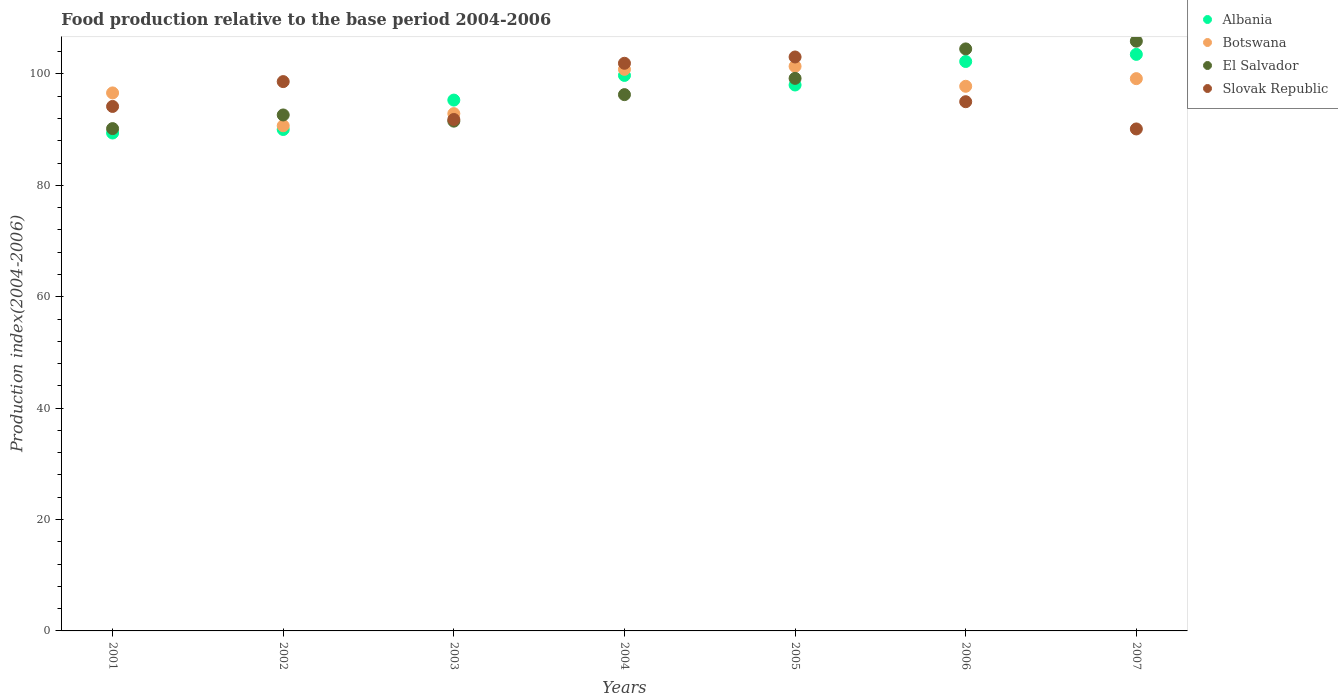Is the number of dotlines equal to the number of legend labels?
Your answer should be very brief. Yes. What is the food production index in Albania in 2006?
Offer a very short reply. 102.24. Across all years, what is the maximum food production index in Slovak Republic?
Keep it short and to the point. 103.05. Across all years, what is the minimum food production index in Slovak Republic?
Make the answer very short. 90.13. In which year was the food production index in Botswana maximum?
Make the answer very short. 2005. What is the total food production index in Botswana in the graph?
Ensure brevity in your answer.  679.33. What is the difference between the food production index in Botswana in 2004 and that in 2007?
Your answer should be compact. 1.67. What is the difference between the food production index in Albania in 2002 and the food production index in El Salvador in 2005?
Provide a succinct answer. -9.18. What is the average food production index in El Salvador per year?
Provide a short and direct response. 97.18. In the year 2003, what is the difference between the food production index in Botswana and food production index in Slovak Republic?
Offer a very short reply. 1.05. What is the ratio of the food production index in Botswana in 2001 to that in 2007?
Keep it short and to the point. 0.97. What is the difference between the highest and the second highest food production index in Albania?
Your response must be concise. 1.28. What is the difference between the highest and the lowest food production index in Albania?
Provide a short and direct response. 14.12. In how many years, is the food production index in El Salvador greater than the average food production index in El Salvador taken over all years?
Keep it short and to the point. 3. Is the food production index in Slovak Republic strictly greater than the food production index in Albania over the years?
Make the answer very short. No. Is the food production index in Slovak Republic strictly less than the food production index in El Salvador over the years?
Make the answer very short. No. Are the values on the major ticks of Y-axis written in scientific E-notation?
Your answer should be very brief. No. Where does the legend appear in the graph?
Your response must be concise. Top right. How are the legend labels stacked?
Your response must be concise. Vertical. What is the title of the graph?
Your answer should be compact. Food production relative to the base period 2004-2006. What is the label or title of the Y-axis?
Offer a very short reply. Production index(2004-2006). What is the Production index(2004-2006) in Albania in 2001?
Offer a very short reply. 89.4. What is the Production index(2004-2006) in Botswana in 2001?
Your answer should be very brief. 96.6. What is the Production index(2004-2006) in El Salvador in 2001?
Offer a terse response. 90.19. What is the Production index(2004-2006) of Slovak Republic in 2001?
Ensure brevity in your answer.  94.17. What is the Production index(2004-2006) in Albania in 2002?
Make the answer very short. 90.03. What is the Production index(2004-2006) of Botswana in 2002?
Give a very brief answer. 90.7. What is the Production index(2004-2006) of El Salvador in 2002?
Your answer should be compact. 92.64. What is the Production index(2004-2006) in Slovak Republic in 2002?
Provide a succinct answer. 98.63. What is the Production index(2004-2006) in Albania in 2003?
Your answer should be compact. 95.31. What is the Production index(2004-2006) in Botswana in 2003?
Offer a terse response. 92.88. What is the Production index(2004-2006) in El Salvador in 2003?
Offer a very short reply. 91.53. What is the Production index(2004-2006) in Slovak Republic in 2003?
Make the answer very short. 91.83. What is the Production index(2004-2006) in Albania in 2004?
Your answer should be very brief. 99.74. What is the Production index(2004-2006) in Botswana in 2004?
Offer a terse response. 100.83. What is the Production index(2004-2006) of El Salvador in 2004?
Keep it short and to the point. 96.29. What is the Production index(2004-2006) of Slovak Republic in 2004?
Keep it short and to the point. 101.92. What is the Production index(2004-2006) in Albania in 2005?
Provide a short and direct response. 98.02. What is the Production index(2004-2006) of Botswana in 2005?
Provide a short and direct response. 101.37. What is the Production index(2004-2006) of El Salvador in 2005?
Offer a terse response. 99.21. What is the Production index(2004-2006) in Slovak Republic in 2005?
Offer a very short reply. 103.05. What is the Production index(2004-2006) of Albania in 2006?
Ensure brevity in your answer.  102.24. What is the Production index(2004-2006) in Botswana in 2006?
Keep it short and to the point. 97.79. What is the Production index(2004-2006) of El Salvador in 2006?
Give a very brief answer. 104.5. What is the Production index(2004-2006) of Slovak Republic in 2006?
Offer a terse response. 95.02. What is the Production index(2004-2006) of Albania in 2007?
Your response must be concise. 103.52. What is the Production index(2004-2006) in Botswana in 2007?
Your response must be concise. 99.16. What is the Production index(2004-2006) in El Salvador in 2007?
Your answer should be very brief. 105.89. What is the Production index(2004-2006) of Slovak Republic in 2007?
Your response must be concise. 90.13. Across all years, what is the maximum Production index(2004-2006) in Albania?
Your answer should be compact. 103.52. Across all years, what is the maximum Production index(2004-2006) of Botswana?
Your answer should be very brief. 101.37. Across all years, what is the maximum Production index(2004-2006) in El Salvador?
Make the answer very short. 105.89. Across all years, what is the maximum Production index(2004-2006) of Slovak Republic?
Your answer should be compact. 103.05. Across all years, what is the minimum Production index(2004-2006) in Albania?
Your response must be concise. 89.4. Across all years, what is the minimum Production index(2004-2006) in Botswana?
Offer a very short reply. 90.7. Across all years, what is the minimum Production index(2004-2006) in El Salvador?
Your answer should be compact. 90.19. Across all years, what is the minimum Production index(2004-2006) of Slovak Republic?
Your answer should be compact. 90.13. What is the total Production index(2004-2006) in Albania in the graph?
Give a very brief answer. 678.26. What is the total Production index(2004-2006) in Botswana in the graph?
Give a very brief answer. 679.33. What is the total Production index(2004-2006) of El Salvador in the graph?
Offer a very short reply. 680.25. What is the total Production index(2004-2006) of Slovak Republic in the graph?
Keep it short and to the point. 674.75. What is the difference between the Production index(2004-2006) of Albania in 2001 and that in 2002?
Your response must be concise. -0.63. What is the difference between the Production index(2004-2006) in El Salvador in 2001 and that in 2002?
Make the answer very short. -2.45. What is the difference between the Production index(2004-2006) in Slovak Republic in 2001 and that in 2002?
Give a very brief answer. -4.46. What is the difference between the Production index(2004-2006) of Albania in 2001 and that in 2003?
Ensure brevity in your answer.  -5.91. What is the difference between the Production index(2004-2006) of Botswana in 2001 and that in 2003?
Give a very brief answer. 3.72. What is the difference between the Production index(2004-2006) in El Salvador in 2001 and that in 2003?
Your answer should be very brief. -1.34. What is the difference between the Production index(2004-2006) in Slovak Republic in 2001 and that in 2003?
Give a very brief answer. 2.34. What is the difference between the Production index(2004-2006) in Albania in 2001 and that in 2004?
Offer a very short reply. -10.34. What is the difference between the Production index(2004-2006) in Botswana in 2001 and that in 2004?
Your answer should be very brief. -4.23. What is the difference between the Production index(2004-2006) of Slovak Republic in 2001 and that in 2004?
Your answer should be compact. -7.75. What is the difference between the Production index(2004-2006) in Albania in 2001 and that in 2005?
Your answer should be compact. -8.62. What is the difference between the Production index(2004-2006) in Botswana in 2001 and that in 2005?
Give a very brief answer. -4.77. What is the difference between the Production index(2004-2006) of El Salvador in 2001 and that in 2005?
Make the answer very short. -9.02. What is the difference between the Production index(2004-2006) in Slovak Republic in 2001 and that in 2005?
Keep it short and to the point. -8.88. What is the difference between the Production index(2004-2006) in Albania in 2001 and that in 2006?
Offer a terse response. -12.84. What is the difference between the Production index(2004-2006) in Botswana in 2001 and that in 2006?
Your answer should be compact. -1.19. What is the difference between the Production index(2004-2006) of El Salvador in 2001 and that in 2006?
Make the answer very short. -14.31. What is the difference between the Production index(2004-2006) in Slovak Republic in 2001 and that in 2006?
Give a very brief answer. -0.85. What is the difference between the Production index(2004-2006) in Albania in 2001 and that in 2007?
Offer a terse response. -14.12. What is the difference between the Production index(2004-2006) in Botswana in 2001 and that in 2007?
Offer a terse response. -2.56. What is the difference between the Production index(2004-2006) in El Salvador in 2001 and that in 2007?
Give a very brief answer. -15.7. What is the difference between the Production index(2004-2006) of Slovak Republic in 2001 and that in 2007?
Your response must be concise. 4.04. What is the difference between the Production index(2004-2006) of Albania in 2002 and that in 2003?
Provide a succinct answer. -5.28. What is the difference between the Production index(2004-2006) of Botswana in 2002 and that in 2003?
Your response must be concise. -2.18. What is the difference between the Production index(2004-2006) in El Salvador in 2002 and that in 2003?
Provide a short and direct response. 1.11. What is the difference between the Production index(2004-2006) in Albania in 2002 and that in 2004?
Ensure brevity in your answer.  -9.71. What is the difference between the Production index(2004-2006) of Botswana in 2002 and that in 2004?
Your answer should be very brief. -10.13. What is the difference between the Production index(2004-2006) of El Salvador in 2002 and that in 2004?
Give a very brief answer. -3.65. What is the difference between the Production index(2004-2006) of Slovak Republic in 2002 and that in 2004?
Offer a very short reply. -3.29. What is the difference between the Production index(2004-2006) of Albania in 2002 and that in 2005?
Give a very brief answer. -7.99. What is the difference between the Production index(2004-2006) in Botswana in 2002 and that in 2005?
Offer a very short reply. -10.67. What is the difference between the Production index(2004-2006) of El Salvador in 2002 and that in 2005?
Provide a short and direct response. -6.57. What is the difference between the Production index(2004-2006) in Slovak Republic in 2002 and that in 2005?
Your answer should be very brief. -4.42. What is the difference between the Production index(2004-2006) in Albania in 2002 and that in 2006?
Provide a short and direct response. -12.21. What is the difference between the Production index(2004-2006) of Botswana in 2002 and that in 2006?
Give a very brief answer. -7.09. What is the difference between the Production index(2004-2006) in El Salvador in 2002 and that in 2006?
Ensure brevity in your answer.  -11.86. What is the difference between the Production index(2004-2006) of Slovak Republic in 2002 and that in 2006?
Your response must be concise. 3.61. What is the difference between the Production index(2004-2006) of Albania in 2002 and that in 2007?
Provide a succinct answer. -13.49. What is the difference between the Production index(2004-2006) in Botswana in 2002 and that in 2007?
Provide a short and direct response. -8.46. What is the difference between the Production index(2004-2006) of El Salvador in 2002 and that in 2007?
Keep it short and to the point. -13.25. What is the difference between the Production index(2004-2006) in Albania in 2003 and that in 2004?
Provide a short and direct response. -4.43. What is the difference between the Production index(2004-2006) of Botswana in 2003 and that in 2004?
Offer a very short reply. -7.95. What is the difference between the Production index(2004-2006) in El Salvador in 2003 and that in 2004?
Provide a short and direct response. -4.76. What is the difference between the Production index(2004-2006) of Slovak Republic in 2003 and that in 2004?
Ensure brevity in your answer.  -10.09. What is the difference between the Production index(2004-2006) in Albania in 2003 and that in 2005?
Make the answer very short. -2.71. What is the difference between the Production index(2004-2006) in Botswana in 2003 and that in 2005?
Provide a succinct answer. -8.49. What is the difference between the Production index(2004-2006) of El Salvador in 2003 and that in 2005?
Your answer should be very brief. -7.68. What is the difference between the Production index(2004-2006) of Slovak Republic in 2003 and that in 2005?
Ensure brevity in your answer.  -11.22. What is the difference between the Production index(2004-2006) in Albania in 2003 and that in 2006?
Offer a very short reply. -6.93. What is the difference between the Production index(2004-2006) in Botswana in 2003 and that in 2006?
Your answer should be very brief. -4.91. What is the difference between the Production index(2004-2006) in El Salvador in 2003 and that in 2006?
Offer a terse response. -12.97. What is the difference between the Production index(2004-2006) in Slovak Republic in 2003 and that in 2006?
Ensure brevity in your answer.  -3.19. What is the difference between the Production index(2004-2006) of Albania in 2003 and that in 2007?
Offer a very short reply. -8.21. What is the difference between the Production index(2004-2006) in Botswana in 2003 and that in 2007?
Provide a succinct answer. -6.28. What is the difference between the Production index(2004-2006) in El Salvador in 2003 and that in 2007?
Your answer should be compact. -14.36. What is the difference between the Production index(2004-2006) in Albania in 2004 and that in 2005?
Provide a short and direct response. 1.72. What is the difference between the Production index(2004-2006) of Botswana in 2004 and that in 2005?
Ensure brevity in your answer.  -0.54. What is the difference between the Production index(2004-2006) of El Salvador in 2004 and that in 2005?
Give a very brief answer. -2.92. What is the difference between the Production index(2004-2006) of Slovak Republic in 2004 and that in 2005?
Your answer should be very brief. -1.13. What is the difference between the Production index(2004-2006) in Botswana in 2004 and that in 2006?
Ensure brevity in your answer.  3.04. What is the difference between the Production index(2004-2006) in El Salvador in 2004 and that in 2006?
Give a very brief answer. -8.21. What is the difference between the Production index(2004-2006) of Albania in 2004 and that in 2007?
Ensure brevity in your answer.  -3.78. What is the difference between the Production index(2004-2006) in Botswana in 2004 and that in 2007?
Provide a short and direct response. 1.67. What is the difference between the Production index(2004-2006) of El Salvador in 2004 and that in 2007?
Your answer should be very brief. -9.6. What is the difference between the Production index(2004-2006) of Slovak Republic in 2004 and that in 2007?
Offer a terse response. 11.79. What is the difference between the Production index(2004-2006) in Albania in 2005 and that in 2006?
Offer a very short reply. -4.22. What is the difference between the Production index(2004-2006) in Botswana in 2005 and that in 2006?
Offer a terse response. 3.58. What is the difference between the Production index(2004-2006) in El Salvador in 2005 and that in 2006?
Ensure brevity in your answer.  -5.29. What is the difference between the Production index(2004-2006) of Slovak Republic in 2005 and that in 2006?
Provide a succinct answer. 8.03. What is the difference between the Production index(2004-2006) in Albania in 2005 and that in 2007?
Offer a terse response. -5.5. What is the difference between the Production index(2004-2006) of Botswana in 2005 and that in 2007?
Provide a succinct answer. 2.21. What is the difference between the Production index(2004-2006) of El Salvador in 2005 and that in 2007?
Your response must be concise. -6.68. What is the difference between the Production index(2004-2006) of Slovak Republic in 2005 and that in 2007?
Your answer should be very brief. 12.92. What is the difference between the Production index(2004-2006) of Albania in 2006 and that in 2007?
Give a very brief answer. -1.28. What is the difference between the Production index(2004-2006) in Botswana in 2006 and that in 2007?
Give a very brief answer. -1.37. What is the difference between the Production index(2004-2006) of El Salvador in 2006 and that in 2007?
Ensure brevity in your answer.  -1.39. What is the difference between the Production index(2004-2006) in Slovak Republic in 2006 and that in 2007?
Offer a very short reply. 4.89. What is the difference between the Production index(2004-2006) of Albania in 2001 and the Production index(2004-2006) of Botswana in 2002?
Provide a short and direct response. -1.3. What is the difference between the Production index(2004-2006) in Albania in 2001 and the Production index(2004-2006) in El Salvador in 2002?
Offer a terse response. -3.24. What is the difference between the Production index(2004-2006) of Albania in 2001 and the Production index(2004-2006) of Slovak Republic in 2002?
Offer a terse response. -9.23. What is the difference between the Production index(2004-2006) of Botswana in 2001 and the Production index(2004-2006) of El Salvador in 2002?
Your response must be concise. 3.96. What is the difference between the Production index(2004-2006) in Botswana in 2001 and the Production index(2004-2006) in Slovak Republic in 2002?
Your answer should be compact. -2.03. What is the difference between the Production index(2004-2006) in El Salvador in 2001 and the Production index(2004-2006) in Slovak Republic in 2002?
Provide a short and direct response. -8.44. What is the difference between the Production index(2004-2006) of Albania in 2001 and the Production index(2004-2006) of Botswana in 2003?
Give a very brief answer. -3.48. What is the difference between the Production index(2004-2006) of Albania in 2001 and the Production index(2004-2006) of El Salvador in 2003?
Your answer should be compact. -2.13. What is the difference between the Production index(2004-2006) in Albania in 2001 and the Production index(2004-2006) in Slovak Republic in 2003?
Make the answer very short. -2.43. What is the difference between the Production index(2004-2006) in Botswana in 2001 and the Production index(2004-2006) in El Salvador in 2003?
Keep it short and to the point. 5.07. What is the difference between the Production index(2004-2006) of Botswana in 2001 and the Production index(2004-2006) of Slovak Republic in 2003?
Provide a succinct answer. 4.77. What is the difference between the Production index(2004-2006) in El Salvador in 2001 and the Production index(2004-2006) in Slovak Republic in 2003?
Your answer should be compact. -1.64. What is the difference between the Production index(2004-2006) of Albania in 2001 and the Production index(2004-2006) of Botswana in 2004?
Your response must be concise. -11.43. What is the difference between the Production index(2004-2006) of Albania in 2001 and the Production index(2004-2006) of El Salvador in 2004?
Provide a succinct answer. -6.89. What is the difference between the Production index(2004-2006) in Albania in 2001 and the Production index(2004-2006) in Slovak Republic in 2004?
Make the answer very short. -12.52. What is the difference between the Production index(2004-2006) in Botswana in 2001 and the Production index(2004-2006) in El Salvador in 2004?
Offer a terse response. 0.31. What is the difference between the Production index(2004-2006) in Botswana in 2001 and the Production index(2004-2006) in Slovak Republic in 2004?
Offer a terse response. -5.32. What is the difference between the Production index(2004-2006) in El Salvador in 2001 and the Production index(2004-2006) in Slovak Republic in 2004?
Keep it short and to the point. -11.73. What is the difference between the Production index(2004-2006) of Albania in 2001 and the Production index(2004-2006) of Botswana in 2005?
Provide a short and direct response. -11.97. What is the difference between the Production index(2004-2006) in Albania in 2001 and the Production index(2004-2006) in El Salvador in 2005?
Keep it short and to the point. -9.81. What is the difference between the Production index(2004-2006) of Albania in 2001 and the Production index(2004-2006) of Slovak Republic in 2005?
Provide a succinct answer. -13.65. What is the difference between the Production index(2004-2006) of Botswana in 2001 and the Production index(2004-2006) of El Salvador in 2005?
Give a very brief answer. -2.61. What is the difference between the Production index(2004-2006) in Botswana in 2001 and the Production index(2004-2006) in Slovak Republic in 2005?
Your response must be concise. -6.45. What is the difference between the Production index(2004-2006) of El Salvador in 2001 and the Production index(2004-2006) of Slovak Republic in 2005?
Your response must be concise. -12.86. What is the difference between the Production index(2004-2006) of Albania in 2001 and the Production index(2004-2006) of Botswana in 2006?
Provide a short and direct response. -8.39. What is the difference between the Production index(2004-2006) of Albania in 2001 and the Production index(2004-2006) of El Salvador in 2006?
Keep it short and to the point. -15.1. What is the difference between the Production index(2004-2006) of Albania in 2001 and the Production index(2004-2006) of Slovak Republic in 2006?
Offer a terse response. -5.62. What is the difference between the Production index(2004-2006) in Botswana in 2001 and the Production index(2004-2006) in El Salvador in 2006?
Your response must be concise. -7.9. What is the difference between the Production index(2004-2006) of Botswana in 2001 and the Production index(2004-2006) of Slovak Republic in 2006?
Offer a terse response. 1.58. What is the difference between the Production index(2004-2006) of El Salvador in 2001 and the Production index(2004-2006) of Slovak Republic in 2006?
Offer a terse response. -4.83. What is the difference between the Production index(2004-2006) of Albania in 2001 and the Production index(2004-2006) of Botswana in 2007?
Make the answer very short. -9.76. What is the difference between the Production index(2004-2006) of Albania in 2001 and the Production index(2004-2006) of El Salvador in 2007?
Provide a succinct answer. -16.49. What is the difference between the Production index(2004-2006) in Albania in 2001 and the Production index(2004-2006) in Slovak Republic in 2007?
Provide a short and direct response. -0.73. What is the difference between the Production index(2004-2006) of Botswana in 2001 and the Production index(2004-2006) of El Salvador in 2007?
Your response must be concise. -9.29. What is the difference between the Production index(2004-2006) of Botswana in 2001 and the Production index(2004-2006) of Slovak Republic in 2007?
Give a very brief answer. 6.47. What is the difference between the Production index(2004-2006) of El Salvador in 2001 and the Production index(2004-2006) of Slovak Republic in 2007?
Your response must be concise. 0.06. What is the difference between the Production index(2004-2006) of Albania in 2002 and the Production index(2004-2006) of Botswana in 2003?
Provide a succinct answer. -2.85. What is the difference between the Production index(2004-2006) of Botswana in 2002 and the Production index(2004-2006) of El Salvador in 2003?
Provide a succinct answer. -0.83. What is the difference between the Production index(2004-2006) in Botswana in 2002 and the Production index(2004-2006) in Slovak Republic in 2003?
Offer a very short reply. -1.13. What is the difference between the Production index(2004-2006) of El Salvador in 2002 and the Production index(2004-2006) of Slovak Republic in 2003?
Your response must be concise. 0.81. What is the difference between the Production index(2004-2006) of Albania in 2002 and the Production index(2004-2006) of Botswana in 2004?
Offer a very short reply. -10.8. What is the difference between the Production index(2004-2006) of Albania in 2002 and the Production index(2004-2006) of El Salvador in 2004?
Offer a terse response. -6.26. What is the difference between the Production index(2004-2006) of Albania in 2002 and the Production index(2004-2006) of Slovak Republic in 2004?
Your answer should be compact. -11.89. What is the difference between the Production index(2004-2006) in Botswana in 2002 and the Production index(2004-2006) in El Salvador in 2004?
Provide a short and direct response. -5.59. What is the difference between the Production index(2004-2006) of Botswana in 2002 and the Production index(2004-2006) of Slovak Republic in 2004?
Your answer should be very brief. -11.22. What is the difference between the Production index(2004-2006) of El Salvador in 2002 and the Production index(2004-2006) of Slovak Republic in 2004?
Your answer should be compact. -9.28. What is the difference between the Production index(2004-2006) of Albania in 2002 and the Production index(2004-2006) of Botswana in 2005?
Provide a succinct answer. -11.34. What is the difference between the Production index(2004-2006) of Albania in 2002 and the Production index(2004-2006) of El Salvador in 2005?
Offer a very short reply. -9.18. What is the difference between the Production index(2004-2006) of Albania in 2002 and the Production index(2004-2006) of Slovak Republic in 2005?
Your response must be concise. -13.02. What is the difference between the Production index(2004-2006) in Botswana in 2002 and the Production index(2004-2006) in El Salvador in 2005?
Keep it short and to the point. -8.51. What is the difference between the Production index(2004-2006) of Botswana in 2002 and the Production index(2004-2006) of Slovak Republic in 2005?
Your answer should be compact. -12.35. What is the difference between the Production index(2004-2006) in El Salvador in 2002 and the Production index(2004-2006) in Slovak Republic in 2005?
Give a very brief answer. -10.41. What is the difference between the Production index(2004-2006) in Albania in 2002 and the Production index(2004-2006) in Botswana in 2006?
Offer a very short reply. -7.76. What is the difference between the Production index(2004-2006) in Albania in 2002 and the Production index(2004-2006) in El Salvador in 2006?
Offer a terse response. -14.47. What is the difference between the Production index(2004-2006) of Albania in 2002 and the Production index(2004-2006) of Slovak Republic in 2006?
Ensure brevity in your answer.  -4.99. What is the difference between the Production index(2004-2006) of Botswana in 2002 and the Production index(2004-2006) of El Salvador in 2006?
Keep it short and to the point. -13.8. What is the difference between the Production index(2004-2006) in Botswana in 2002 and the Production index(2004-2006) in Slovak Republic in 2006?
Provide a short and direct response. -4.32. What is the difference between the Production index(2004-2006) of El Salvador in 2002 and the Production index(2004-2006) of Slovak Republic in 2006?
Make the answer very short. -2.38. What is the difference between the Production index(2004-2006) in Albania in 2002 and the Production index(2004-2006) in Botswana in 2007?
Provide a short and direct response. -9.13. What is the difference between the Production index(2004-2006) in Albania in 2002 and the Production index(2004-2006) in El Salvador in 2007?
Your answer should be compact. -15.86. What is the difference between the Production index(2004-2006) of Albania in 2002 and the Production index(2004-2006) of Slovak Republic in 2007?
Offer a very short reply. -0.1. What is the difference between the Production index(2004-2006) of Botswana in 2002 and the Production index(2004-2006) of El Salvador in 2007?
Provide a succinct answer. -15.19. What is the difference between the Production index(2004-2006) of Botswana in 2002 and the Production index(2004-2006) of Slovak Republic in 2007?
Offer a terse response. 0.57. What is the difference between the Production index(2004-2006) of El Salvador in 2002 and the Production index(2004-2006) of Slovak Republic in 2007?
Give a very brief answer. 2.51. What is the difference between the Production index(2004-2006) of Albania in 2003 and the Production index(2004-2006) of Botswana in 2004?
Keep it short and to the point. -5.52. What is the difference between the Production index(2004-2006) of Albania in 2003 and the Production index(2004-2006) of El Salvador in 2004?
Your answer should be very brief. -0.98. What is the difference between the Production index(2004-2006) in Albania in 2003 and the Production index(2004-2006) in Slovak Republic in 2004?
Provide a short and direct response. -6.61. What is the difference between the Production index(2004-2006) of Botswana in 2003 and the Production index(2004-2006) of El Salvador in 2004?
Give a very brief answer. -3.41. What is the difference between the Production index(2004-2006) of Botswana in 2003 and the Production index(2004-2006) of Slovak Republic in 2004?
Give a very brief answer. -9.04. What is the difference between the Production index(2004-2006) of El Salvador in 2003 and the Production index(2004-2006) of Slovak Republic in 2004?
Provide a short and direct response. -10.39. What is the difference between the Production index(2004-2006) in Albania in 2003 and the Production index(2004-2006) in Botswana in 2005?
Your response must be concise. -6.06. What is the difference between the Production index(2004-2006) in Albania in 2003 and the Production index(2004-2006) in Slovak Republic in 2005?
Provide a succinct answer. -7.74. What is the difference between the Production index(2004-2006) in Botswana in 2003 and the Production index(2004-2006) in El Salvador in 2005?
Your answer should be compact. -6.33. What is the difference between the Production index(2004-2006) of Botswana in 2003 and the Production index(2004-2006) of Slovak Republic in 2005?
Keep it short and to the point. -10.17. What is the difference between the Production index(2004-2006) of El Salvador in 2003 and the Production index(2004-2006) of Slovak Republic in 2005?
Your response must be concise. -11.52. What is the difference between the Production index(2004-2006) in Albania in 2003 and the Production index(2004-2006) in Botswana in 2006?
Give a very brief answer. -2.48. What is the difference between the Production index(2004-2006) in Albania in 2003 and the Production index(2004-2006) in El Salvador in 2006?
Offer a very short reply. -9.19. What is the difference between the Production index(2004-2006) in Albania in 2003 and the Production index(2004-2006) in Slovak Republic in 2006?
Your answer should be very brief. 0.29. What is the difference between the Production index(2004-2006) of Botswana in 2003 and the Production index(2004-2006) of El Salvador in 2006?
Your answer should be very brief. -11.62. What is the difference between the Production index(2004-2006) in Botswana in 2003 and the Production index(2004-2006) in Slovak Republic in 2006?
Offer a terse response. -2.14. What is the difference between the Production index(2004-2006) of El Salvador in 2003 and the Production index(2004-2006) of Slovak Republic in 2006?
Provide a succinct answer. -3.49. What is the difference between the Production index(2004-2006) in Albania in 2003 and the Production index(2004-2006) in Botswana in 2007?
Your answer should be compact. -3.85. What is the difference between the Production index(2004-2006) of Albania in 2003 and the Production index(2004-2006) of El Salvador in 2007?
Offer a terse response. -10.58. What is the difference between the Production index(2004-2006) of Albania in 2003 and the Production index(2004-2006) of Slovak Republic in 2007?
Give a very brief answer. 5.18. What is the difference between the Production index(2004-2006) in Botswana in 2003 and the Production index(2004-2006) in El Salvador in 2007?
Your response must be concise. -13.01. What is the difference between the Production index(2004-2006) in Botswana in 2003 and the Production index(2004-2006) in Slovak Republic in 2007?
Your answer should be very brief. 2.75. What is the difference between the Production index(2004-2006) of El Salvador in 2003 and the Production index(2004-2006) of Slovak Republic in 2007?
Offer a terse response. 1.4. What is the difference between the Production index(2004-2006) in Albania in 2004 and the Production index(2004-2006) in Botswana in 2005?
Your answer should be very brief. -1.63. What is the difference between the Production index(2004-2006) in Albania in 2004 and the Production index(2004-2006) in El Salvador in 2005?
Give a very brief answer. 0.53. What is the difference between the Production index(2004-2006) of Albania in 2004 and the Production index(2004-2006) of Slovak Republic in 2005?
Ensure brevity in your answer.  -3.31. What is the difference between the Production index(2004-2006) in Botswana in 2004 and the Production index(2004-2006) in El Salvador in 2005?
Your answer should be compact. 1.62. What is the difference between the Production index(2004-2006) of Botswana in 2004 and the Production index(2004-2006) of Slovak Republic in 2005?
Offer a very short reply. -2.22. What is the difference between the Production index(2004-2006) of El Salvador in 2004 and the Production index(2004-2006) of Slovak Republic in 2005?
Make the answer very short. -6.76. What is the difference between the Production index(2004-2006) in Albania in 2004 and the Production index(2004-2006) in Botswana in 2006?
Keep it short and to the point. 1.95. What is the difference between the Production index(2004-2006) of Albania in 2004 and the Production index(2004-2006) of El Salvador in 2006?
Your answer should be very brief. -4.76. What is the difference between the Production index(2004-2006) of Albania in 2004 and the Production index(2004-2006) of Slovak Republic in 2006?
Provide a succinct answer. 4.72. What is the difference between the Production index(2004-2006) in Botswana in 2004 and the Production index(2004-2006) in El Salvador in 2006?
Ensure brevity in your answer.  -3.67. What is the difference between the Production index(2004-2006) of Botswana in 2004 and the Production index(2004-2006) of Slovak Republic in 2006?
Make the answer very short. 5.81. What is the difference between the Production index(2004-2006) in El Salvador in 2004 and the Production index(2004-2006) in Slovak Republic in 2006?
Give a very brief answer. 1.27. What is the difference between the Production index(2004-2006) in Albania in 2004 and the Production index(2004-2006) in Botswana in 2007?
Offer a terse response. 0.58. What is the difference between the Production index(2004-2006) of Albania in 2004 and the Production index(2004-2006) of El Salvador in 2007?
Provide a short and direct response. -6.15. What is the difference between the Production index(2004-2006) of Albania in 2004 and the Production index(2004-2006) of Slovak Republic in 2007?
Provide a succinct answer. 9.61. What is the difference between the Production index(2004-2006) of Botswana in 2004 and the Production index(2004-2006) of El Salvador in 2007?
Keep it short and to the point. -5.06. What is the difference between the Production index(2004-2006) in Botswana in 2004 and the Production index(2004-2006) in Slovak Republic in 2007?
Your answer should be very brief. 10.7. What is the difference between the Production index(2004-2006) of El Salvador in 2004 and the Production index(2004-2006) of Slovak Republic in 2007?
Ensure brevity in your answer.  6.16. What is the difference between the Production index(2004-2006) in Albania in 2005 and the Production index(2004-2006) in Botswana in 2006?
Offer a very short reply. 0.23. What is the difference between the Production index(2004-2006) in Albania in 2005 and the Production index(2004-2006) in El Salvador in 2006?
Keep it short and to the point. -6.48. What is the difference between the Production index(2004-2006) of Albania in 2005 and the Production index(2004-2006) of Slovak Republic in 2006?
Ensure brevity in your answer.  3. What is the difference between the Production index(2004-2006) in Botswana in 2005 and the Production index(2004-2006) in El Salvador in 2006?
Make the answer very short. -3.13. What is the difference between the Production index(2004-2006) of Botswana in 2005 and the Production index(2004-2006) of Slovak Republic in 2006?
Give a very brief answer. 6.35. What is the difference between the Production index(2004-2006) in El Salvador in 2005 and the Production index(2004-2006) in Slovak Republic in 2006?
Provide a succinct answer. 4.19. What is the difference between the Production index(2004-2006) in Albania in 2005 and the Production index(2004-2006) in Botswana in 2007?
Ensure brevity in your answer.  -1.14. What is the difference between the Production index(2004-2006) in Albania in 2005 and the Production index(2004-2006) in El Salvador in 2007?
Offer a terse response. -7.87. What is the difference between the Production index(2004-2006) of Albania in 2005 and the Production index(2004-2006) of Slovak Republic in 2007?
Offer a terse response. 7.89. What is the difference between the Production index(2004-2006) in Botswana in 2005 and the Production index(2004-2006) in El Salvador in 2007?
Ensure brevity in your answer.  -4.52. What is the difference between the Production index(2004-2006) in Botswana in 2005 and the Production index(2004-2006) in Slovak Republic in 2007?
Provide a succinct answer. 11.24. What is the difference between the Production index(2004-2006) in El Salvador in 2005 and the Production index(2004-2006) in Slovak Republic in 2007?
Your answer should be very brief. 9.08. What is the difference between the Production index(2004-2006) of Albania in 2006 and the Production index(2004-2006) of Botswana in 2007?
Make the answer very short. 3.08. What is the difference between the Production index(2004-2006) in Albania in 2006 and the Production index(2004-2006) in El Salvador in 2007?
Ensure brevity in your answer.  -3.65. What is the difference between the Production index(2004-2006) in Albania in 2006 and the Production index(2004-2006) in Slovak Republic in 2007?
Offer a very short reply. 12.11. What is the difference between the Production index(2004-2006) of Botswana in 2006 and the Production index(2004-2006) of Slovak Republic in 2007?
Your answer should be compact. 7.66. What is the difference between the Production index(2004-2006) in El Salvador in 2006 and the Production index(2004-2006) in Slovak Republic in 2007?
Offer a terse response. 14.37. What is the average Production index(2004-2006) in Albania per year?
Provide a succinct answer. 96.89. What is the average Production index(2004-2006) of Botswana per year?
Provide a short and direct response. 97.05. What is the average Production index(2004-2006) in El Salvador per year?
Your answer should be very brief. 97.18. What is the average Production index(2004-2006) of Slovak Republic per year?
Provide a succinct answer. 96.39. In the year 2001, what is the difference between the Production index(2004-2006) in Albania and Production index(2004-2006) in El Salvador?
Provide a short and direct response. -0.79. In the year 2001, what is the difference between the Production index(2004-2006) of Albania and Production index(2004-2006) of Slovak Republic?
Offer a terse response. -4.77. In the year 2001, what is the difference between the Production index(2004-2006) of Botswana and Production index(2004-2006) of El Salvador?
Offer a terse response. 6.41. In the year 2001, what is the difference between the Production index(2004-2006) of Botswana and Production index(2004-2006) of Slovak Republic?
Offer a very short reply. 2.43. In the year 2001, what is the difference between the Production index(2004-2006) of El Salvador and Production index(2004-2006) of Slovak Republic?
Offer a very short reply. -3.98. In the year 2002, what is the difference between the Production index(2004-2006) of Albania and Production index(2004-2006) of Botswana?
Offer a terse response. -0.67. In the year 2002, what is the difference between the Production index(2004-2006) of Albania and Production index(2004-2006) of El Salvador?
Ensure brevity in your answer.  -2.61. In the year 2002, what is the difference between the Production index(2004-2006) of Botswana and Production index(2004-2006) of El Salvador?
Make the answer very short. -1.94. In the year 2002, what is the difference between the Production index(2004-2006) of Botswana and Production index(2004-2006) of Slovak Republic?
Provide a short and direct response. -7.93. In the year 2002, what is the difference between the Production index(2004-2006) of El Salvador and Production index(2004-2006) of Slovak Republic?
Offer a very short reply. -5.99. In the year 2003, what is the difference between the Production index(2004-2006) in Albania and Production index(2004-2006) in Botswana?
Your answer should be very brief. 2.43. In the year 2003, what is the difference between the Production index(2004-2006) of Albania and Production index(2004-2006) of El Salvador?
Ensure brevity in your answer.  3.78. In the year 2003, what is the difference between the Production index(2004-2006) in Albania and Production index(2004-2006) in Slovak Republic?
Your answer should be very brief. 3.48. In the year 2003, what is the difference between the Production index(2004-2006) in Botswana and Production index(2004-2006) in El Salvador?
Provide a short and direct response. 1.35. In the year 2004, what is the difference between the Production index(2004-2006) of Albania and Production index(2004-2006) of Botswana?
Ensure brevity in your answer.  -1.09. In the year 2004, what is the difference between the Production index(2004-2006) of Albania and Production index(2004-2006) of El Salvador?
Your answer should be compact. 3.45. In the year 2004, what is the difference between the Production index(2004-2006) of Albania and Production index(2004-2006) of Slovak Republic?
Offer a terse response. -2.18. In the year 2004, what is the difference between the Production index(2004-2006) in Botswana and Production index(2004-2006) in El Salvador?
Make the answer very short. 4.54. In the year 2004, what is the difference between the Production index(2004-2006) in Botswana and Production index(2004-2006) in Slovak Republic?
Offer a very short reply. -1.09. In the year 2004, what is the difference between the Production index(2004-2006) of El Salvador and Production index(2004-2006) of Slovak Republic?
Your answer should be very brief. -5.63. In the year 2005, what is the difference between the Production index(2004-2006) in Albania and Production index(2004-2006) in Botswana?
Ensure brevity in your answer.  -3.35. In the year 2005, what is the difference between the Production index(2004-2006) in Albania and Production index(2004-2006) in El Salvador?
Provide a short and direct response. -1.19. In the year 2005, what is the difference between the Production index(2004-2006) of Albania and Production index(2004-2006) of Slovak Republic?
Make the answer very short. -5.03. In the year 2005, what is the difference between the Production index(2004-2006) in Botswana and Production index(2004-2006) in El Salvador?
Provide a succinct answer. 2.16. In the year 2005, what is the difference between the Production index(2004-2006) of Botswana and Production index(2004-2006) of Slovak Republic?
Your response must be concise. -1.68. In the year 2005, what is the difference between the Production index(2004-2006) of El Salvador and Production index(2004-2006) of Slovak Republic?
Your response must be concise. -3.84. In the year 2006, what is the difference between the Production index(2004-2006) of Albania and Production index(2004-2006) of Botswana?
Keep it short and to the point. 4.45. In the year 2006, what is the difference between the Production index(2004-2006) in Albania and Production index(2004-2006) in El Salvador?
Your answer should be very brief. -2.26. In the year 2006, what is the difference between the Production index(2004-2006) of Albania and Production index(2004-2006) of Slovak Republic?
Your response must be concise. 7.22. In the year 2006, what is the difference between the Production index(2004-2006) of Botswana and Production index(2004-2006) of El Salvador?
Your answer should be compact. -6.71. In the year 2006, what is the difference between the Production index(2004-2006) in Botswana and Production index(2004-2006) in Slovak Republic?
Provide a short and direct response. 2.77. In the year 2006, what is the difference between the Production index(2004-2006) in El Salvador and Production index(2004-2006) in Slovak Republic?
Give a very brief answer. 9.48. In the year 2007, what is the difference between the Production index(2004-2006) of Albania and Production index(2004-2006) of Botswana?
Keep it short and to the point. 4.36. In the year 2007, what is the difference between the Production index(2004-2006) in Albania and Production index(2004-2006) in El Salvador?
Provide a short and direct response. -2.37. In the year 2007, what is the difference between the Production index(2004-2006) in Albania and Production index(2004-2006) in Slovak Republic?
Make the answer very short. 13.39. In the year 2007, what is the difference between the Production index(2004-2006) in Botswana and Production index(2004-2006) in El Salvador?
Provide a succinct answer. -6.73. In the year 2007, what is the difference between the Production index(2004-2006) of Botswana and Production index(2004-2006) of Slovak Republic?
Keep it short and to the point. 9.03. In the year 2007, what is the difference between the Production index(2004-2006) in El Salvador and Production index(2004-2006) in Slovak Republic?
Your answer should be very brief. 15.76. What is the ratio of the Production index(2004-2006) in Albania in 2001 to that in 2002?
Offer a very short reply. 0.99. What is the ratio of the Production index(2004-2006) of Botswana in 2001 to that in 2002?
Keep it short and to the point. 1.06. What is the ratio of the Production index(2004-2006) of El Salvador in 2001 to that in 2002?
Provide a succinct answer. 0.97. What is the ratio of the Production index(2004-2006) of Slovak Republic in 2001 to that in 2002?
Offer a terse response. 0.95. What is the ratio of the Production index(2004-2006) of Albania in 2001 to that in 2003?
Provide a short and direct response. 0.94. What is the ratio of the Production index(2004-2006) in Botswana in 2001 to that in 2003?
Your answer should be compact. 1.04. What is the ratio of the Production index(2004-2006) in El Salvador in 2001 to that in 2003?
Ensure brevity in your answer.  0.99. What is the ratio of the Production index(2004-2006) in Slovak Republic in 2001 to that in 2003?
Your answer should be very brief. 1.03. What is the ratio of the Production index(2004-2006) in Albania in 2001 to that in 2004?
Offer a very short reply. 0.9. What is the ratio of the Production index(2004-2006) in Botswana in 2001 to that in 2004?
Offer a very short reply. 0.96. What is the ratio of the Production index(2004-2006) in El Salvador in 2001 to that in 2004?
Ensure brevity in your answer.  0.94. What is the ratio of the Production index(2004-2006) in Slovak Republic in 2001 to that in 2004?
Make the answer very short. 0.92. What is the ratio of the Production index(2004-2006) of Albania in 2001 to that in 2005?
Offer a very short reply. 0.91. What is the ratio of the Production index(2004-2006) of Botswana in 2001 to that in 2005?
Ensure brevity in your answer.  0.95. What is the ratio of the Production index(2004-2006) in Slovak Republic in 2001 to that in 2005?
Provide a short and direct response. 0.91. What is the ratio of the Production index(2004-2006) in Albania in 2001 to that in 2006?
Make the answer very short. 0.87. What is the ratio of the Production index(2004-2006) of Botswana in 2001 to that in 2006?
Ensure brevity in your answer.  0.99. What is the ratio of the Production index(2004-2006) in El Salvador in 2001 to that in 2006?
Your answer should be compact. 0.86. What is the ratio of the Production index(2004-2006) of Albania in 2001 to that in 2007?
Provide a short and direct response. 0.86. What is the ratio of the Production index(2004-2006) of Botswana in 2001 to that in 2007?
Your answer should be compact. 0.97. What is the ratio of the Production index(2004-2006) in El Salvador in 2001 to that in 2007?
Offer a very short reply. 0.85. What is the ratio of the Production index(2004-2006) in Slovak Republic in 2001 to that in 2007?
Offer a very short reply. 1.04. What is the ratio of the Production index(2004-2006) in Albania in 2002 to that in 2003?
Keep it short and to the point. 0.94. What is the ratio of the Production index(2004-2006) of Botswana in 2002 to that in 2003?
Keep it short and to the point. 0.98. What is the ratio of the Production index(2004-2006) of El Salvador in 2002 to that in 2003?
Give a very brief answer. 1.01. What is the ratio of the Production index(2004-2006) of Slovak Republic in 2002 to that in 2003?
Make the answer very short. 1.07. What is the ratio of the Production index(2004-2006) in Albania in 2002 to that in 2004?
Make the answer very short. 0.9. What is the ratio of the Production index(2004-2006) of Botswana in 2002 to that in 2004?
Provide a succinct answer. 0.9. What is the ratio of the Production index(2004-2006) in El Salvador in 2002 to that in 2004?
Provide a succinct answer. 0.96. What is the ratio of the Production index(2004-2006) in Slovak Republic in 2002 to that in 2004?
Your answer should be compact. 0.97. What is the ratio of the Production index(2004-2006) of Albania in 2002 to that in 2005?
Provide a succinct answer. 0.92. What is the ratio of the Production index(2004-2006) in Botswana in 2002 to that in 2005?
Provide a short and direct response. 0.89. What is the ratio of the Production index(2004-2006) in El Salvador in 2002 to that in 2005?
Keep it short and to the point. 0.93. What is the ratio of the Production index(2004-2006) of Slovak Republic in 2002 to that in 2005?
Offer a very short reply. 0.96. What is the ratio of the Production index(2004-2006) of Albania in 2002 to that in 2006?
Offer a terse response. 0.88. What is the ratio of the Production index(2004-2006) in Botswana in 2002 to that in 2006?
Offer a very short reply. 0.93. What is the ratio of the Production index(2004-2006) of El Salvador in 2002 to that in 2006?
Make the answer very short. 0.89. What is the ratio of the Production index(2004-2006) of Slovak Republic in 2002 to that in 2006?
Give a very brief answer. 1.04. What is the ratio of the Production index(2004-2006) in Albania in 2002 to that in 2007?
Offer a very short reply. 0.87. What is the ratio of the Production index(2004-2006) in Botswana in 2002 to that in 2007?
Offer a terse response. 0.91. What is the ratio of the Production index(2004-2006) in El Salvador in 2002 to that in 2007?
Your response must be concise. 0.87. What is the ratio of the Production index(2004-2006) of Slovak Republic in 2002 to that in 2007?
Offer a very short reply. 1.09. What is the ratio of the Production index(2004-2006) of Albania in 2003 to that in 2004?
Your answer should be compact. 0.96. What is the ratio of the Production index(2004-2006) of Botswana in 2003 to that in 2004?
Offer a terse response. 0.92. What is the ratio of the Production index(2004-2006) of El Salvador in 2003 to that in 2004?
Offer a very short reply. 0.95. What is the ratio of the Production index(2004-2006) in Slovak Republic in 2003 to that in 2004?
Offer a very short reply. 0.9. What is the ratio of the Production index(2004-2006) of Albania in 2003 to that in 2005?
Make the answer very short. 0.97. What is the ratio of the Production index(2004-2006) of Botswana in 2003 to that in 2005?
Ensure brevity in your answer.  0.92. What is the ratio of the Production index(2004-2006) in El Salvador in 2003 to that in 2005?
Keep it short and to the point. 0.92. What is the ratio of the Production index(2004-2006) in Slovak Republic in 2003 to that in 2005?
Your answer should be very brief. 0.89. What is the ratio of the Production index(2004-2006) of Albania in 2003 to that in 2006?
Provide a short and direct response. 0.93. What is the ratio of the Production index(2004-2006) in Botswana in 2003 to that in 2006?
Your answer should be compact. 0.95. What is the ratio of the Production index(2004-2006) of El Salvador in 2003 to that in 2006?
Keep it short and to the point. 0.88. What is the ratio of the Production index(2004-2006) of Slovak Republic in 2003 to that in 2006?
Your answer should be very brief. 0.97. What is the ratio of the Production index(2004-2006) in Albania in 2003 to that in 2007?
Your response must be concise. 0.92. What is the ratio of the Production index(2004-2006) of Botswana in 2003 to that in 2007?
Provide a succinct answer. 0.94. What is the ratio of the Production index(2004-2006) of El Salvador in 2003 to that in 2007?
Your answer should be very brief. 0.86. What is the ratio of the Production index(2004-2006) in Slovak Republic in 2003 to that in 2007?
Offer a very short reply. 1.02. What is the ratio of the Production index(2004-2006) in Albania in 2004 to that in 2005?
Provide a succinct answer. 1.02. What is the ratio of the Production index(2004-2006) of Botswana in 2004 to that in 2005?
Your answer should be very brief. 0.99. What is the ratio of the Production index(2004-2006) in El Salvador in 2004 to that in 2005?
Make the answer very short. 0.97. What is the ratio of the Production index(2004-2006) in Albania in 2004 to that in 2006?
Provide a short and direct response. 0.98. What is the ratio of the Production index(2004-2006) of Botswana in 2004 to that in 2006?
Make the answer very short. 1.03. What is the ratio of the Production index(2004-2006) in El Salvador in 2004 to that in 2006?
Keep it short and to the point. 0.92. What is the ratio of the Production index(2004-2006) of Slovak Republic in 2004 to that in 2006?
Provide a succinct answer. 1.07. What is the ratio of the Production index(2004-2006) of Albania in 2004 to that in 2007?
Ensure brevity in your answer.  0.96. What is the ratio of the Production index(2004-2006) in Botswana in 2004 to that in 2007?
Offer a terse response. 1.02. What is the ratio of the Production index(2004-2006) in El Salvador in 2004 to that in 2007?
Provide a succinct answer. 0.91. What is the ratio of the Production index(2004-2006) in Slovak Republic in 2004 to that in 2007?
Your response must be concise. 1.13. What is the ratio of the Production index(2004-2006) in Albania in 2005 to that in 2006?
Your answer should be compact. 0.96. What is the ratio of the Production index(2004-2006) of Botswana in 2005 to that in 2006?
Make the answer very short. 1.04. What is the ratio of the Production index(2004-2006) in El Salvador in 2005 to that in 2006?
Ensure brevity in your answer.  0.95. What is the ratio of the Production index(2004-2006) in Slovak Republic in 2005 to that in 2006?
Provide a succinct answer. 1.08. What is the ratio of the Production index(2004-2006) of Albania in 2005 to that in 2007?
Make the answer very short. 0.95. What is the ratio of the Production index(2004-2006) of Botswana in 2005 to that in 2007?
Your response must be concise. 1.02. What is the ratio of the Production index(2004-2006) of El Salvador in 2005 to that in 2007?
Your response must be concise. 0.94. What is the ratio of the Production index(2004-2006) of Slovak Republic in 2005 to that in 2007?
Offer a very short reply. 1.14. What is the ratio of the Production index(2004-2006) in Albania in 2006 to that in 2007?
Ensure brevity in your answer.  0.99. What is the ratio of the Production index(2004-2006) of Botswana in 2006 to that in 2007?
Provide a succinct answer. 0.99. What is the ratio of the Production index(2004-2006) in El Salvador in 2006 to that in 2007?
Offer a very short reply. 0.99. What is the ratio of the Production index(2004-2006) in Slovak Republic in 2006 to that in 2007?
Provide a short and direct response. 1.05. What is the difference between the highest and the second highest Production index(2004-2006) in Albania?
Provide a succinct answer. 1.28. What is the difference between the highest and the second highest Production index(2004-2006) of Botswana?
Offer a terse response. 0.54. What is the difference between the highest and the second highest Production index(2004-2006) of El Salvador?
Your response must be concise. 1.39. What is the difference between the highest and the second highest Production index(2004-2006) of Slovak Republic?
Keep it short and to the point. 1.13. What is the difference between the highest and the lowest Production index(2004-2006) in Albania?
Ensure brevity in your answer.  14.12. What is the difference between the highest and the lowest Production index(2004-2006) in Botswana?
Offer a terse response. 10.67. What is the difference between the highest and the lowest Production index(2004-2006) of Slovak Republic?
Make the answer very short. 12.92. 